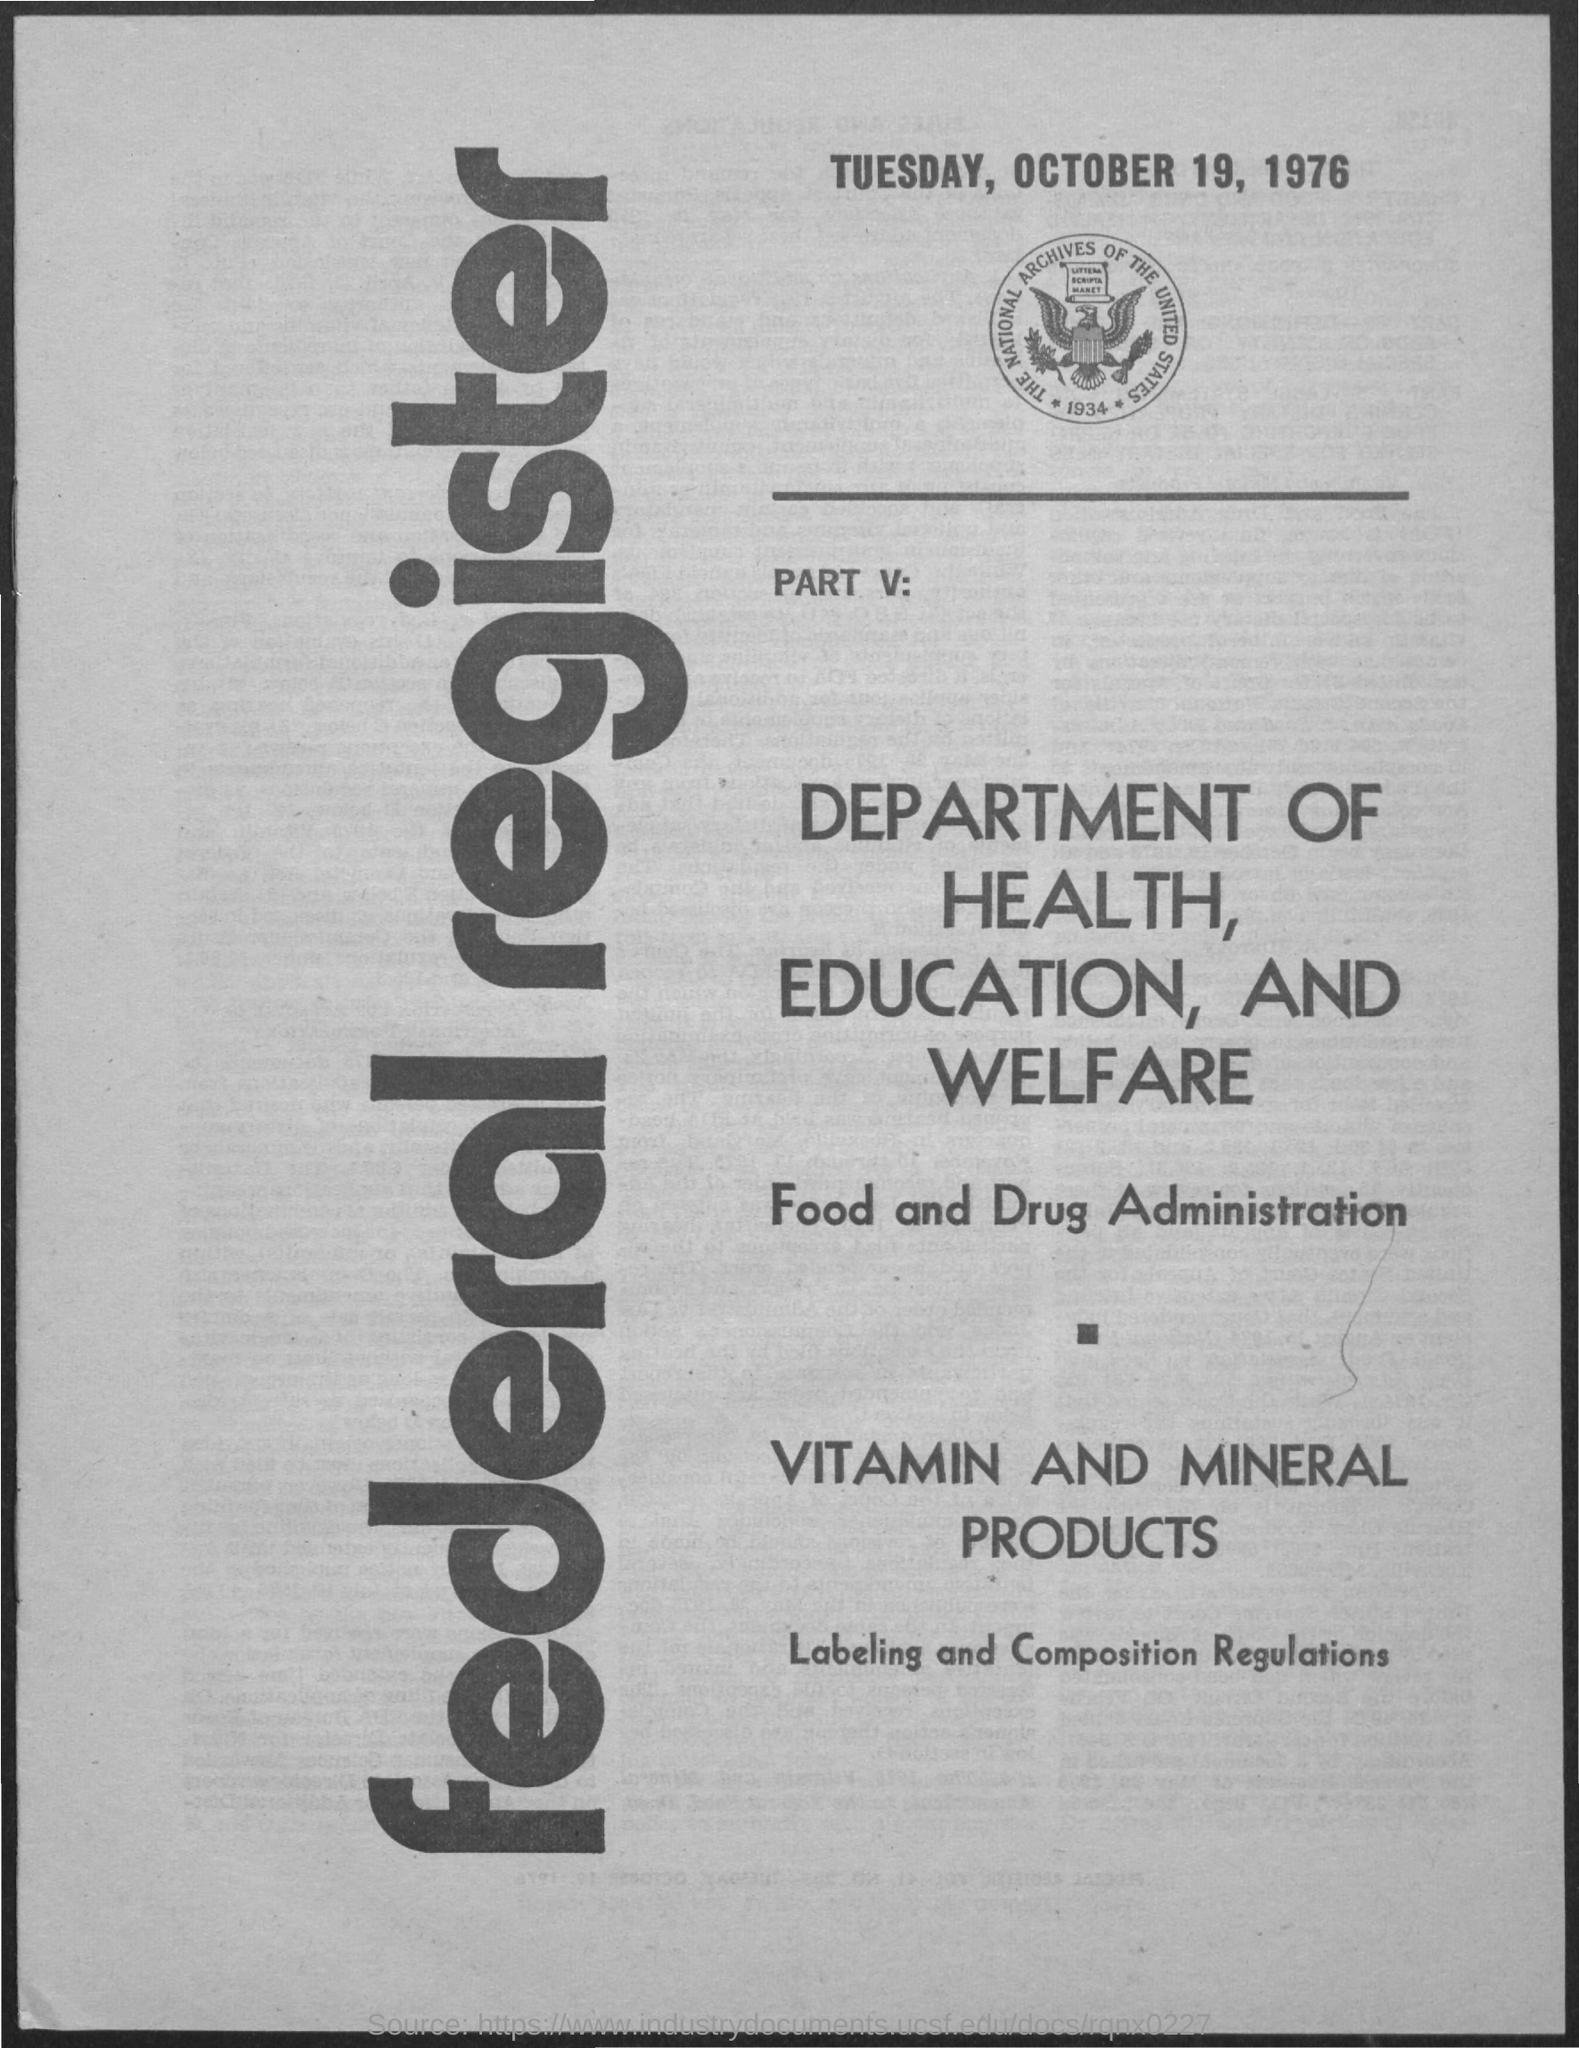Give some essential details in this illustration. The date mentioned in the document is Tuesday, October 19, 1976. The year depicted in the image is 1934. The first title in the vertical format is the Federal Register. 